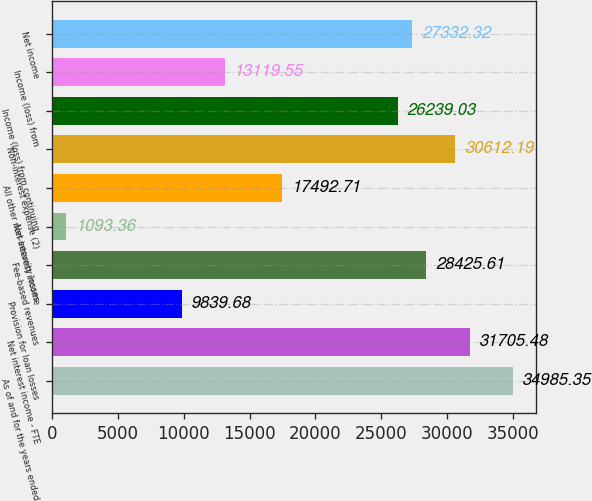<chart> <loc_0><loc_0><loc_500><loc_500><bar_chart><fcel>As of and for the years ended<fcel>Net interest income - FTE<fcel>Provision for loan losses<fcel>Fee-based revenues<fcel>Net security losses<fcel>All other non-interest income<fcel>Non-interest expense (2)<fcel>Income (loss) from continuing<fcel>Income (loss) from<fcel>Net income<nl><fcel>34985.3<fcel>31705.5<fcel>9839.68<fcel>28425.6<fcel>1093.36<fcel>17492.7<fcel>30612.2<fcel>26239<fcel>13119.5<fcel>27332.3<nl></chart> 